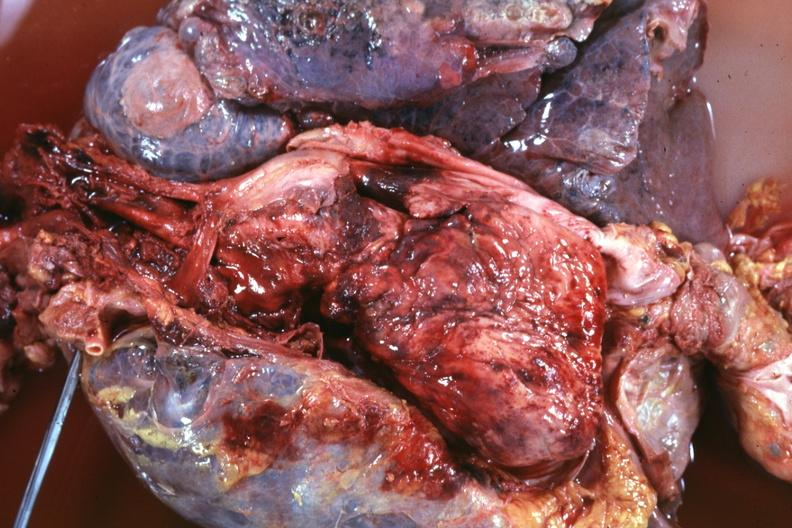s lesion of myocytolysis present?
Answer the question using a single word or phrase. No 